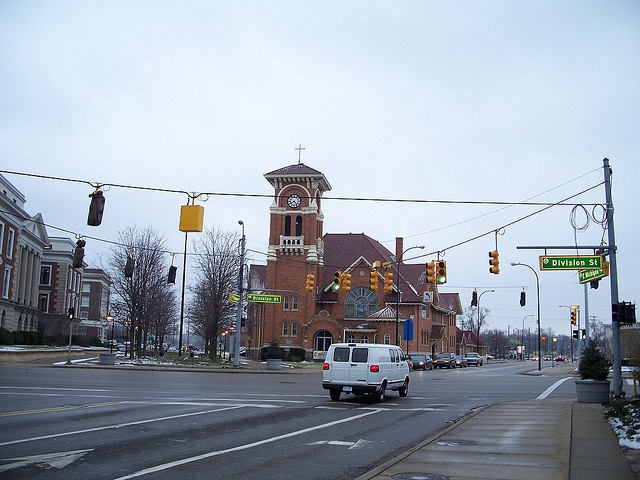Describe the objects in this image and their specific colors. I can see car in lightblue, black, darkgray, and gray tones, traffic light in lightblue, black, lightgray, gray, and navy tones, traffic light in lightblue, olive, and tan tones, traffic light in lightblue, black, and gray tones, and car in lightblue, black, gray, and darkgray tones in this image. 